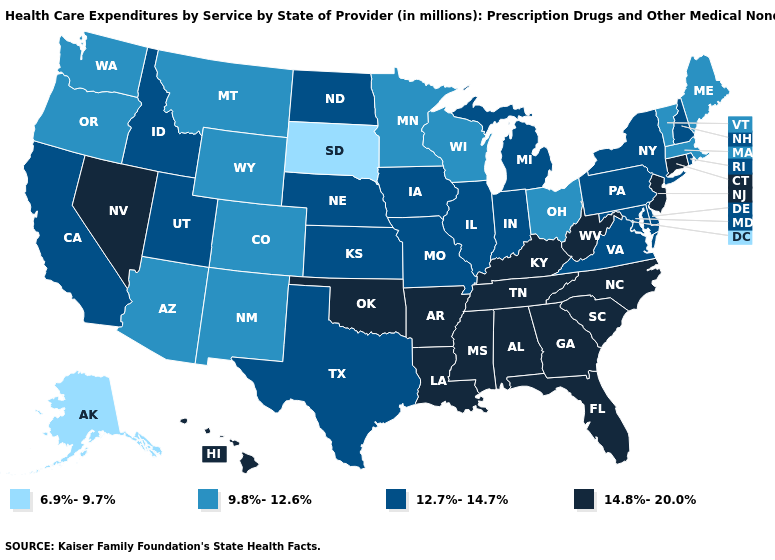Name the states that have a value in the range 14.8%-20.0%?
Give a very brief answer. Alabama, Arkansas, Connecticut, Florida, Georgia, Hawaii, Kentucky, Louisiana, Mississippi, Nevada, New Jersey, North Carolina, Oklahoma, South Carolina, Tennessee, West Virginia. What is the value of Virginia?
Keep it brief. 12.7%-14.7%. Does Michigan have a lower value than Tennessee?
Be succinct. Yes. What is the value of Florida?
Quick response, please. 14.8%-20.0%. What is the value of Nebraska?
Concise answer only. 12.7%-14.7%. Does South Dakota have the lowest value in the USA?
Concise answer only. Yes. Name the states that have a value in the range 9.8%-12.6%?
Keep it brief. Arizona, Colorado, Maine, Massachusetts, Minnesota, Montana, New Mexico, Ohio, Oregon, Vermont, Washington, Wisconsin, Wyoming. Which states have the highest value in the USA?
Answer briefly. Alabama, Arkansas, Connecticut, Florida, Georgia, Hawaii, Kentucky, Louisiana, Mississippi, Nevada, New Jersey, North Carolina, Oklahoma, South Carolina, Tennessee, West Virginia. What is the lowest value in states that border Wisconsin?
Concise answer only. 9.8%-12.6%. What is the value of Hawaii?
Be succinct. 14.8%-20.0%. What is the lowest value in the Northeast?
Quick response, please. 9.8%-12.6%. Among the states that border Rhode Island , which have the highest value?
Concise answer only. Connecticut. Name the states that have a value in the range 6.9%-9.7%?
Write a very short answer. Alaska, South Dakota. Does Minnesota have the same value as Ohio?
Keep it brief. Yes. Name the states that have a value in the range 6.9%-9.7%?
Concise answer only. Alaska, South Dakota. 